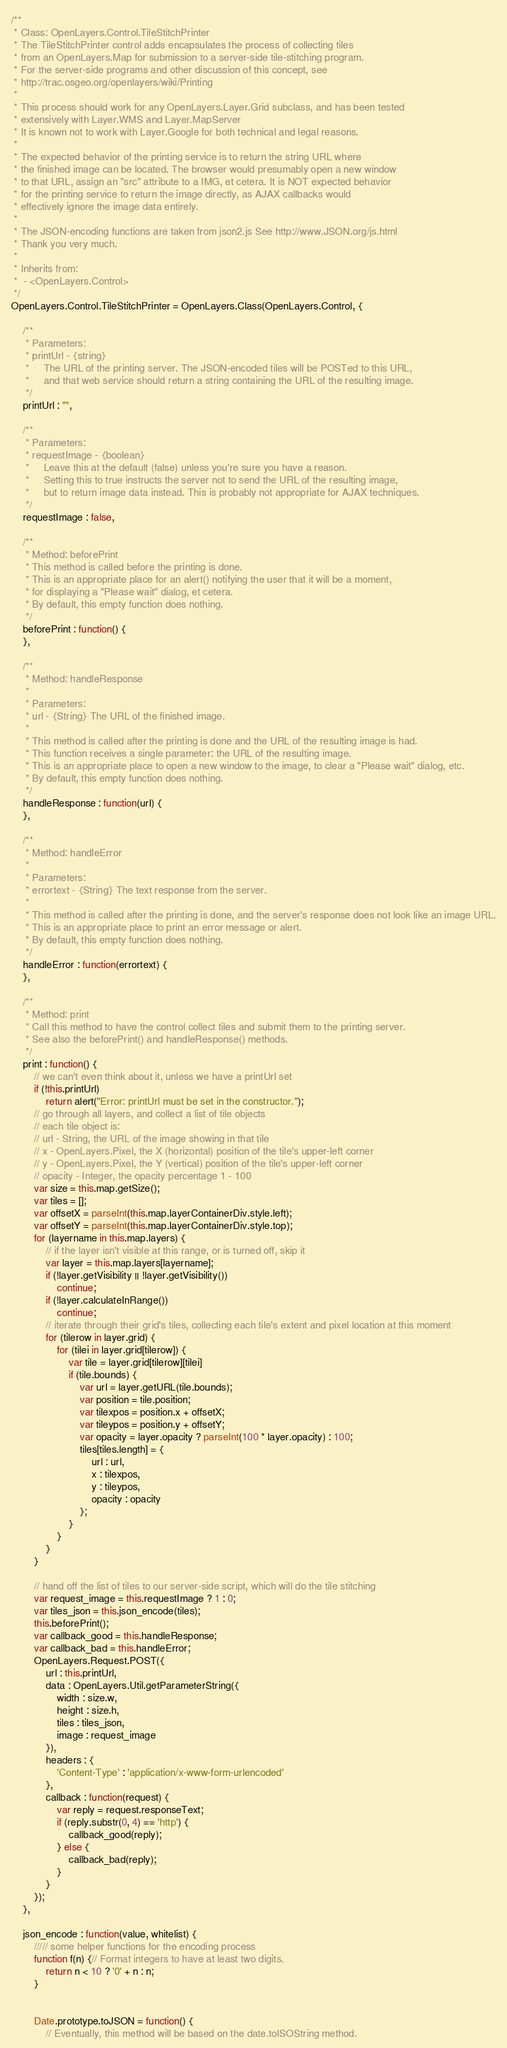<code> <loc_0><loc_0><loc_500><loc_500><_JavaScript_>/**
 * Class: OpenLayers.Control.TileStitchPrinter
 * The TileStitchPrinter control adds encapsulates the process of collecting tiles
 * from an OpenLayers.Map for submission to a server-side tile-stitching program.
 * For the server-side programs and other discussion of this concept, see
 * http://trac.osgeo.org/openlayers/wiki/Printing
 *
 * This process should work for any OpenLayers.Layer.Grid subclass, and has been tested
 * extensively with Layer.WMS and Layer.MapServer
 * It is known not to work with Layer.Google for both technical and legal reasons.
 *
 * The expected behavior of the printing service is to return the string URL where
 * the finished image can be located. The browser would presumably open a new window
 * to that URL, assign an "src" attribute to a IMG, et cetera. It is NOT expected behavior
 * for the printing service to return the image directly, as AJAX callbacks would
 * effectively ignore the image data entirely.
 *
 * The JSON-encoding functions are taken from json2.js See http://www.JSON.org/js.html
 * Thank you very much.
 *
 * Inherits from:
 *  - <OpenLayers.Control>
 */
OpenLayers.Control.TileStitchPrinter = OpenLayers.Class(OpenLayers.Control, {

	/**
	 * Parameters:
	 * printUrl - {string}
	 *     The URL of the printing server. The JSON-encoded tiles will be POSTed to this URL,
	 *     and that web service should return a string containing the URL of the resulting image.
	 */
	printUrl : "",

	/**
	 * Parameters:
	 * requestImage - {boolean}
	 *     Leave this at the default (false) unless you're sure you have a reason.
	 *     Setting this to true instructs the server not to send the URL of the resulting image,
	 *     but to return image data instead. This is probably not appropriate for AJAX techniques.
	 */
	requestImage : false,

	/**
	 * Method: beforePrint
	 * This method is called before the printing is done.
	 * This is an appropriate place for an alert() notifying the user that it will be a moment,
	 * for displaying a "Please wait" dialog, et cetera.
	 * By default, this empty function does nothing.
	 */
	beforePrint : function() {
	},

	/**
	 * Method: handleResponse
	 *
	 * Parameters:
	 * url - {String} The URL of the finished image.
	 *
	 * This method is called after the printing is done and the URL of the resulting image is had.
	 * This function receives a single parameter: the URL of the resulting image.
	 * This is an appropriate place to open a new window to the image, to clear a "Please wait" dialog, etc.
	 * By default, this empty function does nothing.
	 */
	handleResponse : function(url) {
	},

	/**
	 * Method: handleError
	 *
	 * Parameters:
	 * errortext - {String} The text response from the server.
	 *
	 * This method is called after the printing is done, and the server's response does not look like an image URL.
	 * This is an appropriate place to print an error message or alert.
	 * By default, this empty function does nothing.
	 */
	handleError : function(errortext) {
	},

	/**
	 * Method: print
	 * Call this method to have the control collect tiles and submit them to the printing server.
	 * See also the beforePrint() and handleResponse() methods.
	 */
	print : function() {
		// we can't even think about it, unless we have a printUrl set
		if (!this.printUrl)
			return alert("Error: printUrl must be set in the constructor.");
		// go through all layers, and collect a list of tile objects
		// each tile object is:
		// url - String, the URL of the image showing in that tile
		// x - OpenLayers.Pixel, the X (horizontal) position of the tile's upper-left corner
		// y - OpenLayers.Pixel, the Y (vertical) position of the tile's upper-left corner
		// opacity - Integer, the opacity percentage 1 - 100
		var size = this.map.getSize();
		var tiles = [];
		var offsetX = parseInt(this.map.layerContainerDiv.style.left);
		var offsetY = parseInt(this.map.layerContainerDiv.style.top);
		for (layername in this.map.layers) {
			// if the layer isn't visible at this range, or is turned off, skip it
			var layer = this.map.layers[layername];
			if (!layer.getVisibility || !layer.getVisibility())
				continue;
			if (!layer.calculateInRange())
				continue;
			// iterate through their grid's tiles, collecting each tile's extent and pixel location at this moment
			for (tilerow in layer.grid) {
				for (tilei in layer.grid[tilerow]) {
					var tile = layer.grid[tilerow][tilei]
					if (tile.bounds) {
						var url = layer.getURL(tile.bounds);
						var position = tile.position;
						var tilexpos = position.x + offsetX;
						var tileypos = position.y + offsetY;
						var opacity = layer.opacity ? parseInt(100 * layer.opacity) : 100;
						tiles[tiles.length] = {
							url : url,
							x : tilexpos,
							y : tileypos,
							opacity : opacity
						};
					}
				}
			}
		}

		// hand off the list of tiles to our server-side script, which will do the tile stitching
		var request_image = this.requestImage ? 1 : 0;
		var tiles_json = this.json_encode(tiles);
		this.beforePrint();
		var callback_good = this.handleResponse;
		var callback_bad = this.handleError;
		OpenLayers.Request.POST({
			url : this.printUrl,
			data : OpenLayers.Util.getParameterString({
				width : size.w,
				height : size.h,
				tiles : tiles_json,
				image : request_image
			}),
			headers : {
				'Content-Type' : 'application/x-www-form-urlencoded'
			},
			callback : function(request) {
				var reply = request.responseText;
				if (reply.substr(0, 4) == 'http') {
					callback_good(reply);
				} else {
					callback_bad(reply);
				}
			}
		});
	},

	json_encode : function(value, whitelist) {
		///// some helper functions for the encoding process
		function f(n) {// Format integers to have at least two digits.
			return n < 10 ? '0' + n : n;
		}


		Date.prototype.toJSON = function() {
			// Eventually, this method will be based on the date.toISOString method.</code> 